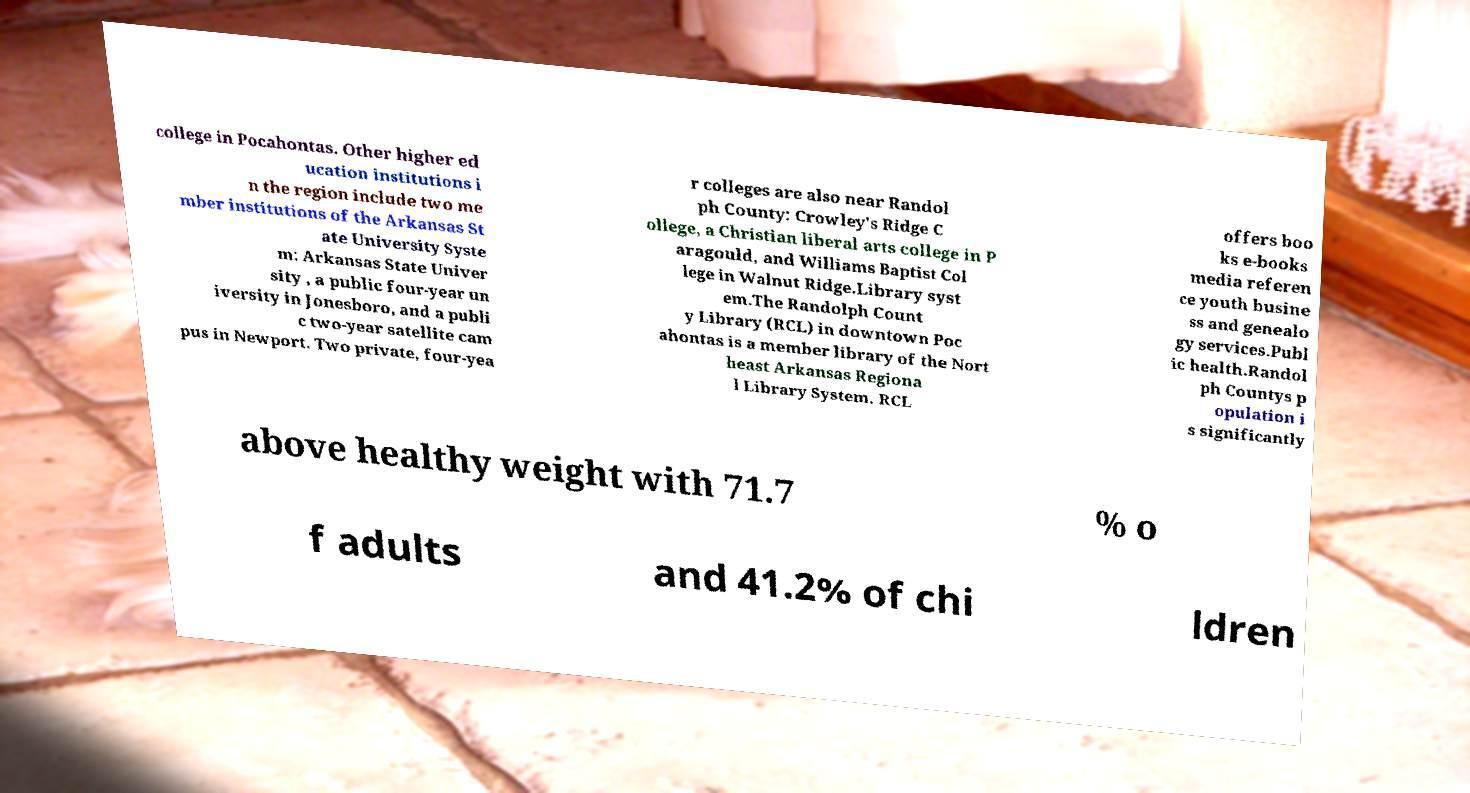Can you read and provide the text displayed in the image?This photo seems to have some interesting text. Can you extract and type it out for me? college in Pocahontas. Other higher ed ucation institutions i n the region include two me mber institutions of the Arkansas St ate University Syste m: Arkansas State Univer sity , a public four-year un iversity in Jonesboro, and a publi c two-year satellite cam pus in Newport. Two private, four-yea r colleges are also near Randol ph County: Crowley's Ridge C ollege, a Christian liberal arts college in P aragould, and Williams Baptist Col lege in Walnut Ridge.Library syst em.The Randolph Count y Library (RCL) in downtown Poc ahontas is a member library of the Nort heast Arkansas Regiona l Library System. RCL offers boo ks e-books media referen ce youth busine ss and genealo gy services.Publ ic health.Randol ph Countys p opulation i s significantly above healthy weight with 71.7 % o f adults and 41.2% of chi ldren 